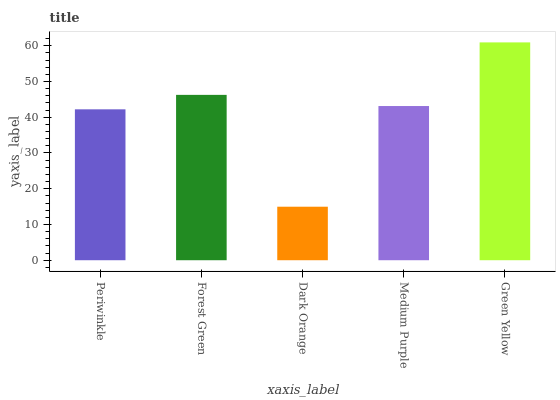Is Dark Orange the minimum?
Answer yes or no. Yes. Is Green Yellow the maximum?
Answer yes or no. Yes. Is Forest Green the minimum?
Answer yes or no. No. Is Forest Green the maximum?
Answer yes or no. No. Is Forest Green greater than Periwinkle?
Answer yes or no. Yes. Is Periwinkle less than Forest Green?
Answer yes or no. Yes. Is Periwinkle greater than Forest Green?
Answer yes or no. No. Is Forest Green less than Periwinkle?
Answer yes or no. No. Is Medium Purple the high median?
Answer yes or no. Yes. Is Medium Purple the low median?
Answer yes or no. Yes. Is Periwinkle the high median?
Answer yes or no. No. Is Dark Orange the low median?
Answer yes or no. No. 